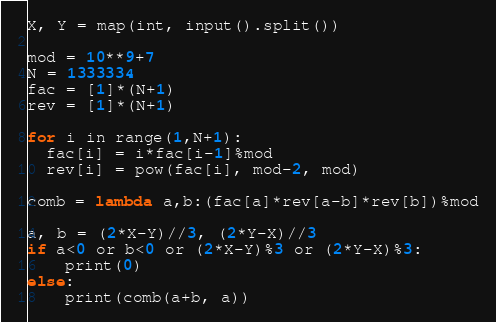<code> <loc_0><loc_0><loc_500><loc_500><_Python_>X, Y = map(int, input().split())

mod = 10**9+7
N = 1333334
fac = [1]*(N+1)
rev = [1]*(N+1)
 
for i in range(1,N+1):
  fac[i] = i*fac[i-1]%mod
  rev[i] = pow(fac[i], mod-2, mod)
 
comb = lambda a,b:(fac[a]*rev[a-b]*rev[b])%mod

a, b = (2*X-Y)//3, (2*Y-X)//3
if a<0 or b<0 or (2*X-Y)%3 or (2*Y-X)%3:
    print(0)
else:
    print(comb(a+b, a))
</code> 